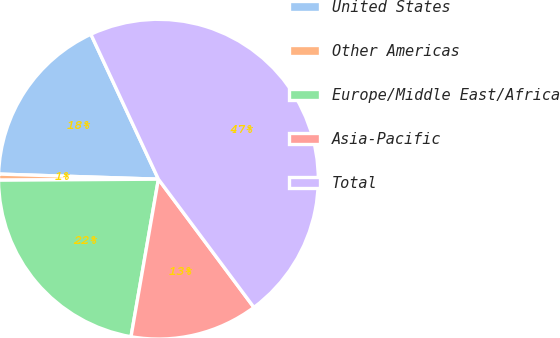Convert chart. <chart><loc_0><loc_0><loc_500><loc_500><pie_chart><fcel>United States<fcel>Other Americas<fcel>Europe/Middle East/Africa<fcel>Asia-Pacific<fcel>Total<nl><fcel>17.55%<fcel>0.61%<fcel>22.16%<fcel>12.93%<fcel>46.75%<nl></chart> 